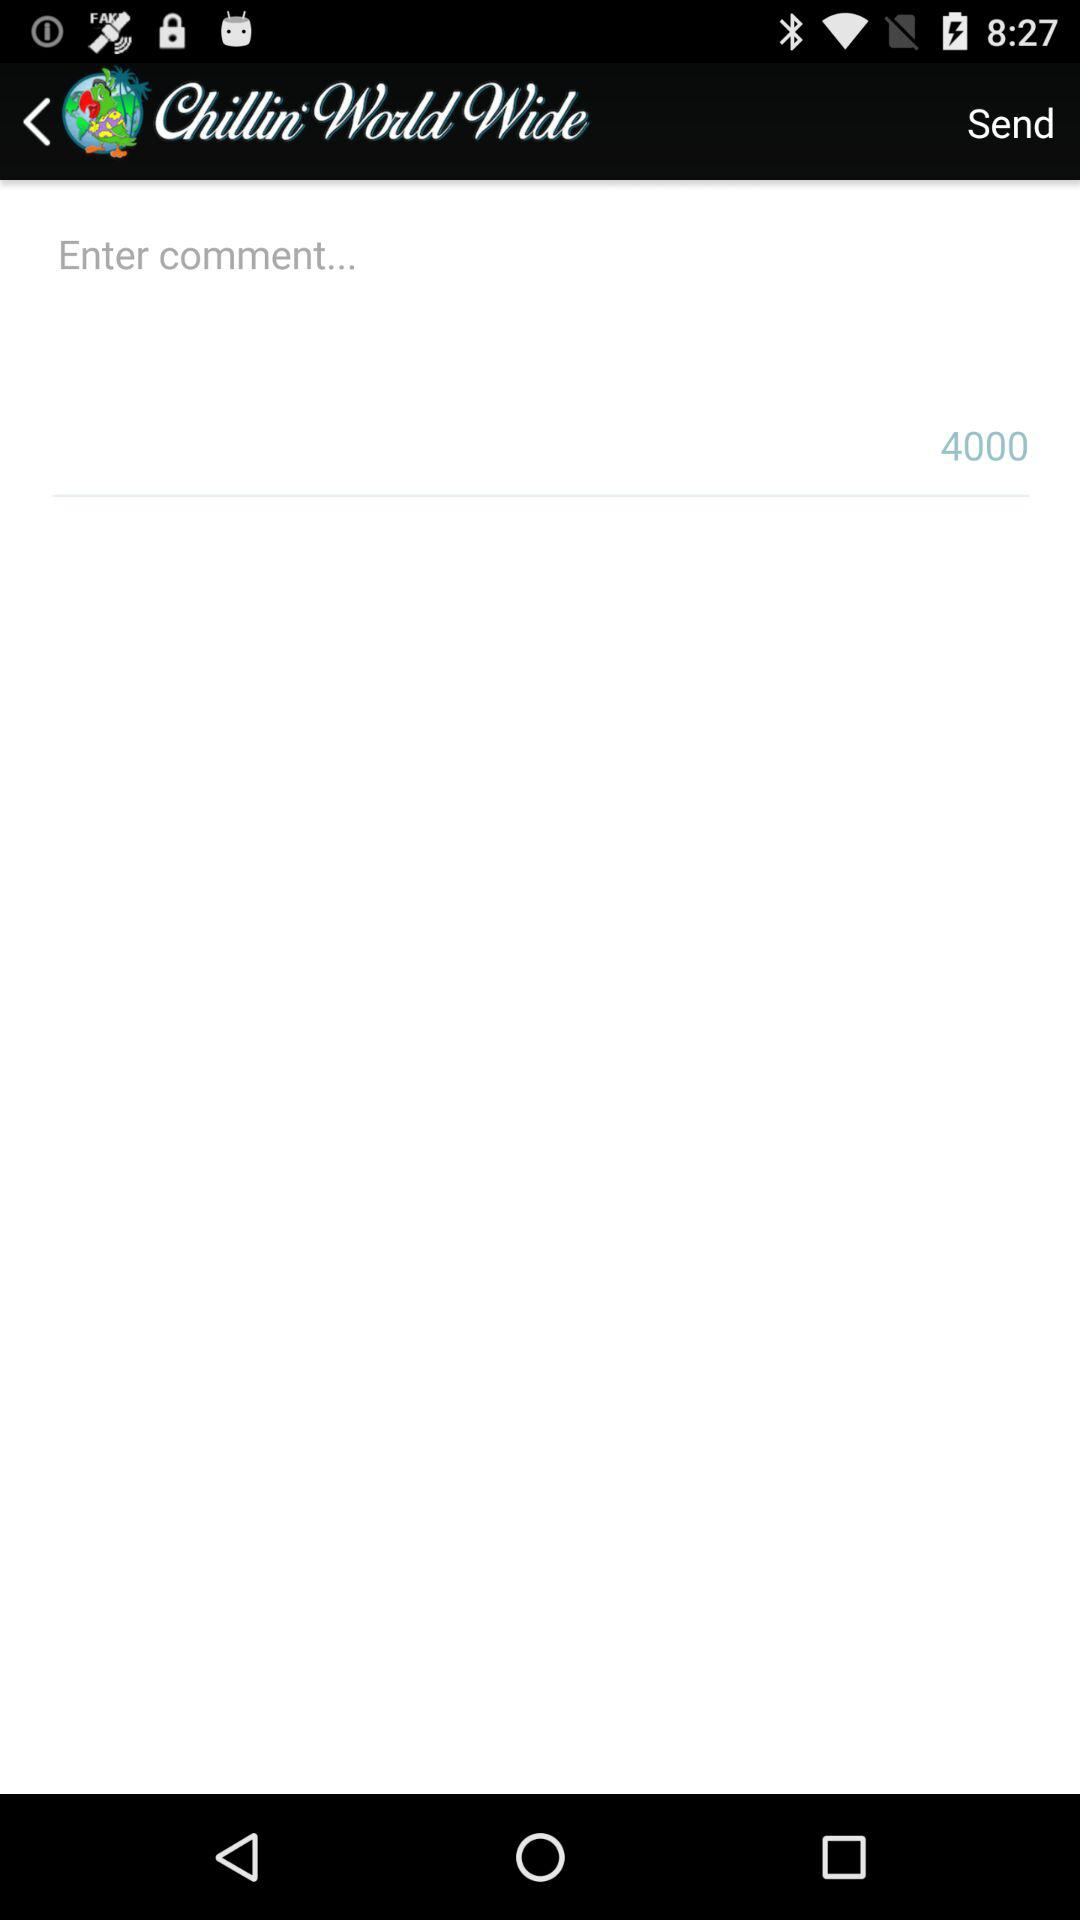What is the maximum text limit for sending a comment? The maximum text limit for sending a comment is 4000. 